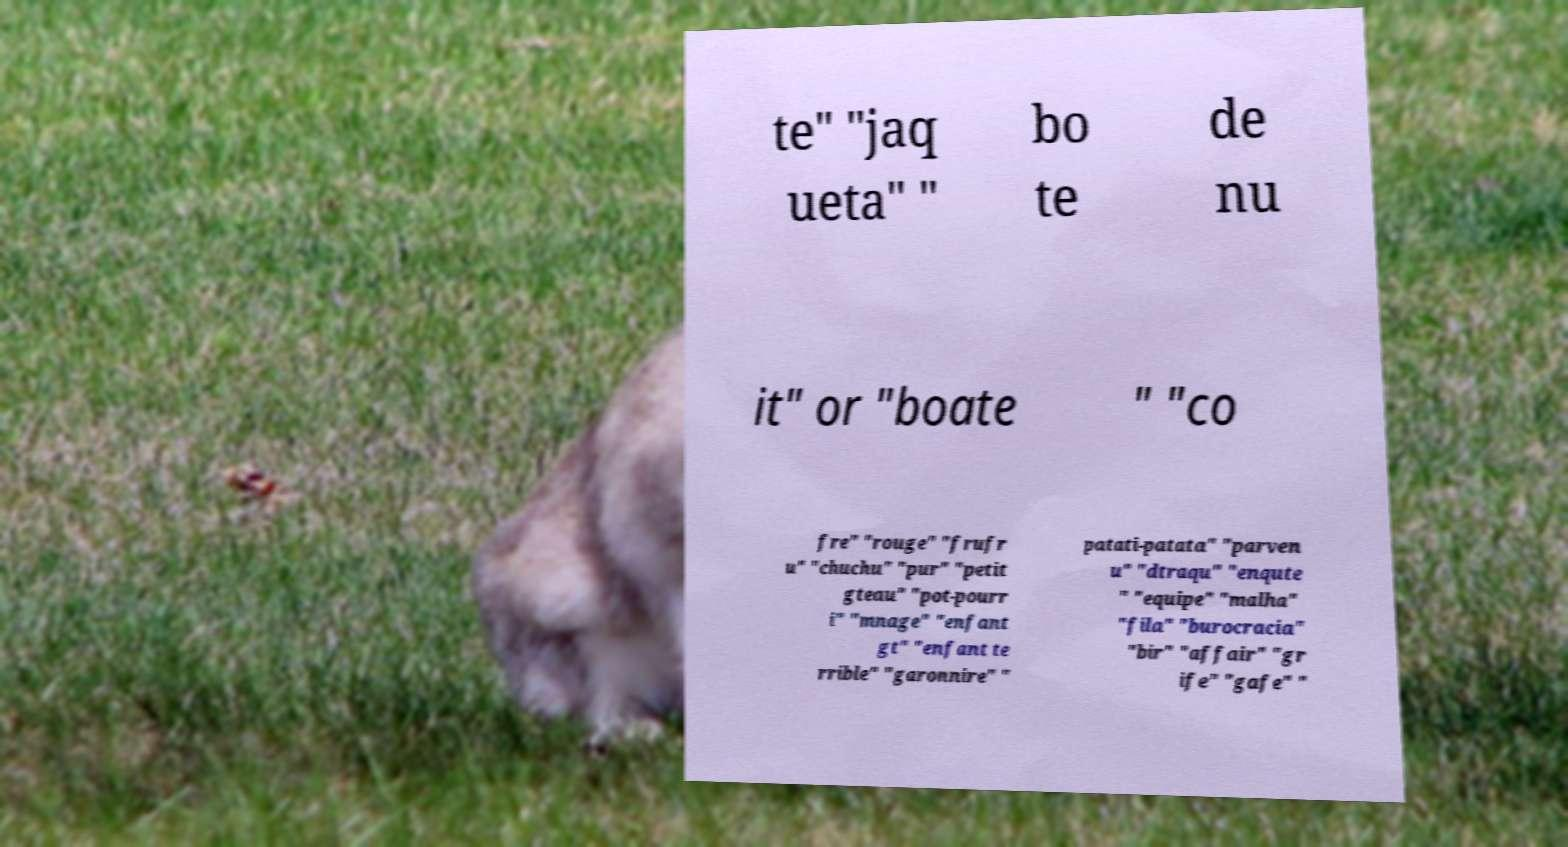Please read and relay the text visible in this image. What does it say? te" "jaq ueta" " bo te de nu it" or "boate " "co fre" "rouge" "frufr u" "chuchu" "pur" "petit gteau" "pot-pourr i" "mnage" "enfant gt" "enfant te rrible" "garonnire" " patati-patata" "parven u" "dtraqu" "enqute " "equipe" "malha" "fila" "burocracia" "bir" "affair" "gr ife" "gafe" " 